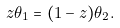Convert formula to latex. <formula><loc_0><loc_0><loc_500><loc_500>z \theta _ { 1 } = ( 1 - z ) \theta _ { 2 } .</formula> 